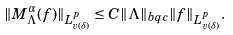<formula> <loc_0><loc_0><loc_500><loc_500>\| M ^ { \alpha } _ { \Lambda } ( f ) \| _ { L ^ { p } _ { v ( \delta ) } } \leq C \| \Lambda \| _ { b q c } \| f \| _ { L ^ { p } _ { v ( \delta ) } } .</formula> 